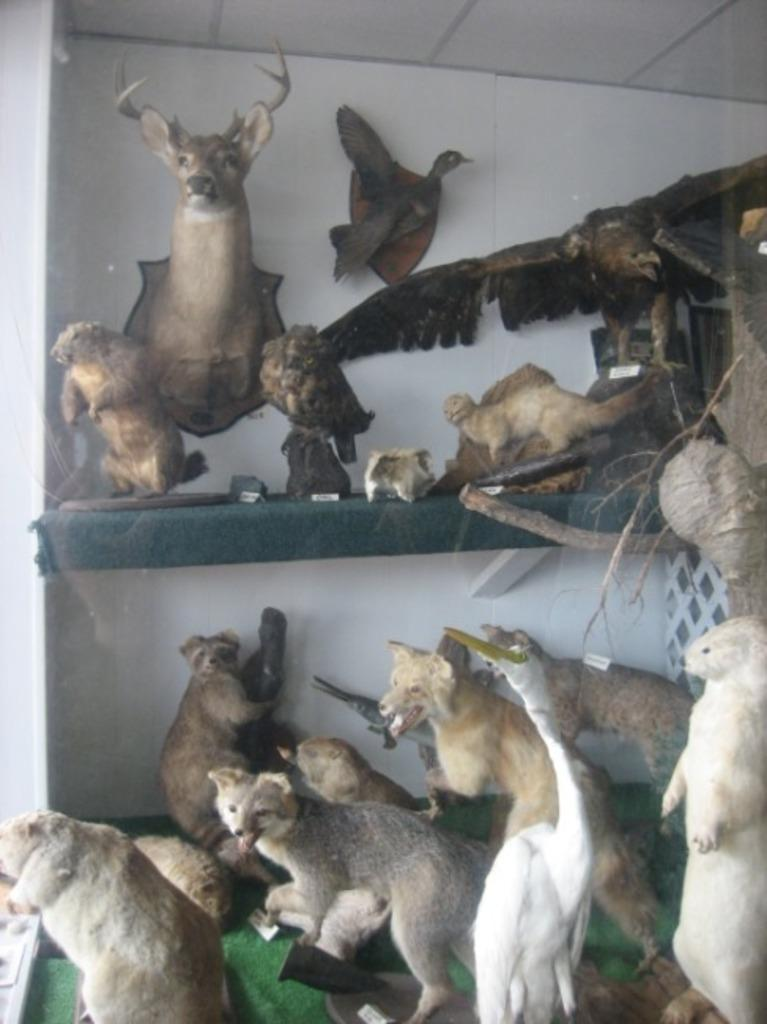What can be seen in the image in terms of objects? There are many toys in the image. What types of animals do the toys represent? The toys represent different animals. What is visible in the background of the image? There is a wall in the background of the image. What type of tent is set up in the image? There is no tent present in the image; it features many toys representing different animals. 